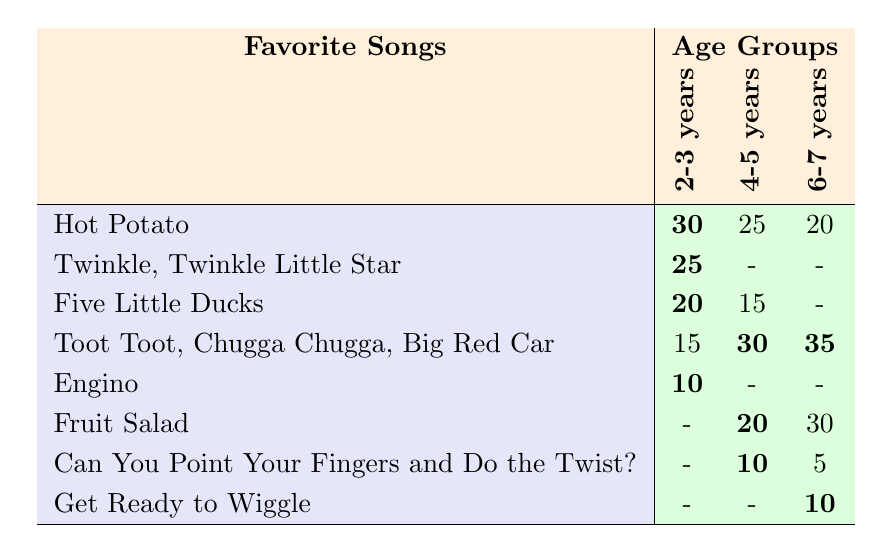What is the favorite song of the 2-3 years age group with the highest preference? Looking at the row for the 2-3 years age group, "Hot Potato" has the highest value of 30.
Answer: Hot Potato Which song is equally liked by the 4-5 years and 6-7 years age groups? Checking the counts for the 4-5 years and 6-7 years, "Toot Toot, Chugga Chugga, Big Red Car" is present in both rows with the values 30 and 35, respectively, indicating equal appeal.
Answer: No song is equally liked What is the total preference score for "Five Little Ducks" across all age groups? The score for "Five Little Ducks" in the 2-3 years age group is 20 and in the 4-5 years age group it is 15. It is not present for the 6-7 years group. Adding these gives 20 + 15 = 35.
Answer: 35 Which age group has the least favorite song as "Can You Point Your Fingers and Do the Twist?" For "Can You Point Your Fingers and Do the Twist?", the values across age groups are 0 for 2-3 years, 10 for 4-5 years, and 5 for 6-7 years. The least preference is 5 in the 6-7 years age group.
Answer: 6-7 years Is it true that "Twinkle, Twinkle Little Star" is preferred by both the 2-3 years age group and any other age group? "Twinkle, Twinkle Little Star" shows a value of 25 only in the 2-3 years age group, with no appearance in other age groups, making it a unique preference.
Answer: No What is the average preference score for the song "Fruit Salad" across the age groups? The scores for "Fruit Salad" in the age groups are 0 in 2-3 years, 20 in 4-5 years, and 30 in 6-7 years. This gives a total of 0 + 20 + 30 = 50. Since there are 3 age groups, the average is 50/3, which is approximately 16.67.
Answer: 16.67 What song has the same score in both the 4-5 and 6-7 years age groups? The score for "Can You Point Your Fingers and Do the Twist?" is 10 in 4-5 years and 5 in 6-7 years, while "Fruit Salad" shows 20 in 4-5 and 30 in 6-7, thus no song has the same score across both groups.
Answer: No song has the same score Which song was liked more by the 6-7 years age group than the 4-5 years age group? In the age group data, every song's score for the 6-7 years age group is higher than that of the 4-5 years group for "Toot Toot" and "Fruit Salad". Notably, "Toot Toot, Chugga Chugga, Big Red Car" is 35 vs 30.
Answer: Toot Toot, Chugga Chugga, Big Red Car and Fruit Salad Which song is most popular among the 4-5 years age group? In the 4-5 years group, the highest score recorded is for "Toot Toot, Chugga Chugga, Big Red Car" which is 30.
Answer: Toot Toot, Chugga Chugga, Big Red Car 